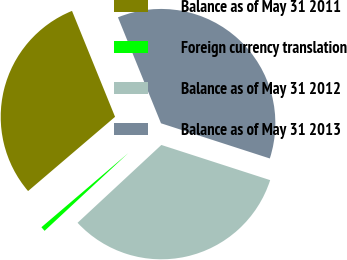Convert chart. <chart><loc_0><loc_0><loc_500><loc_500><pie_chart><fcel>Balance as of May 31 2011<fcel>Foreign currency translation<fcel>Balance as of May 31 2012<fcel>Balance as of May 31 2013<nl><fcel>30.1%<fcel>0.67%<fcel>33.11%<fcel>36.12%<nl></chart> 